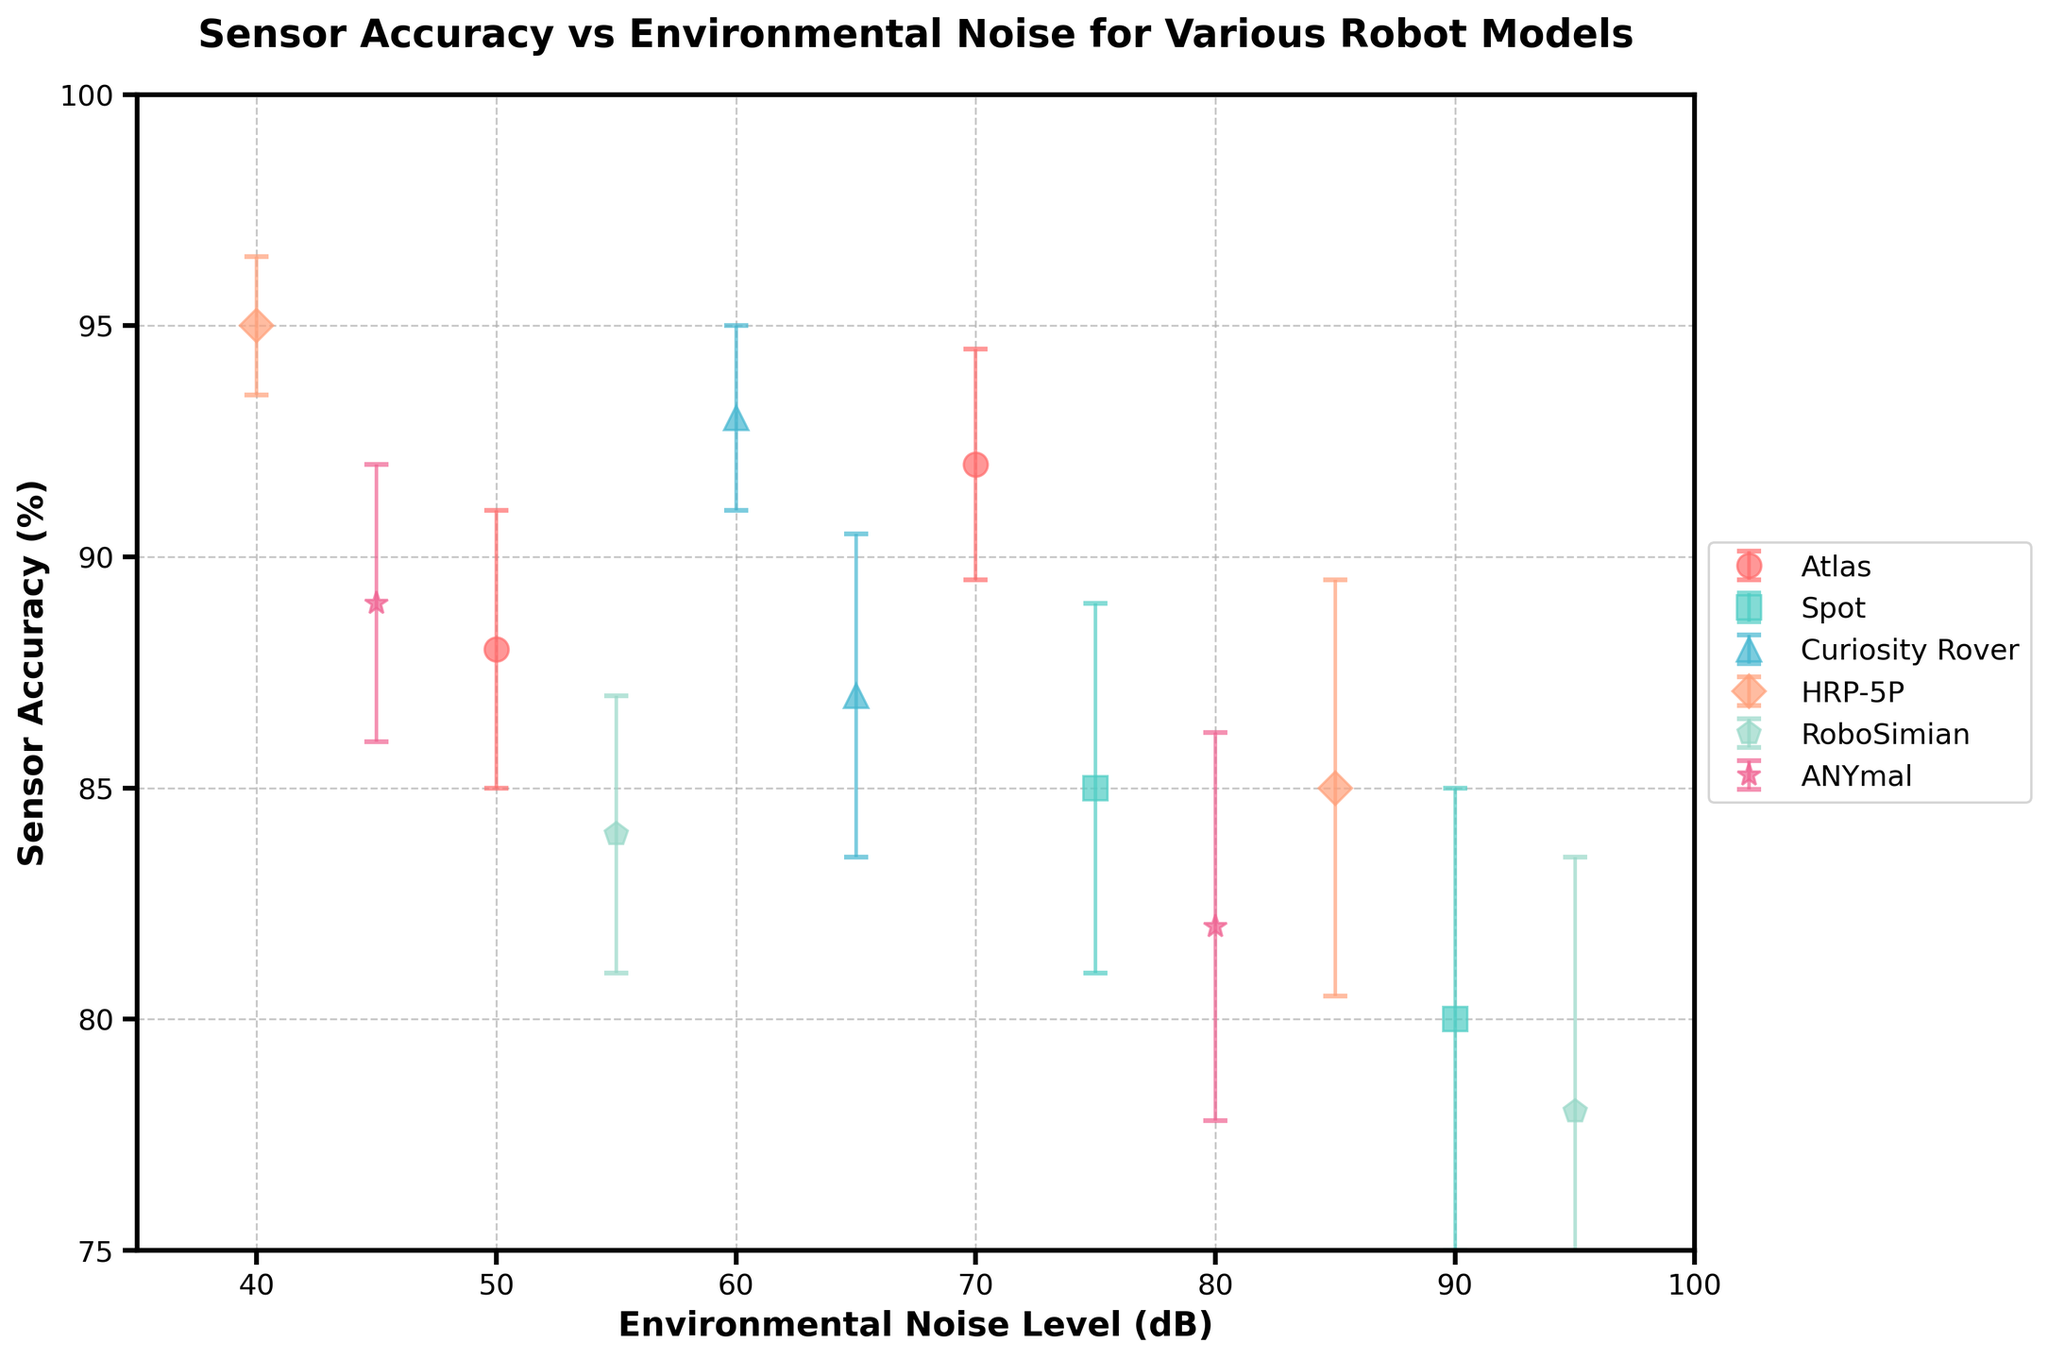what is the highest sensor accuracy value? By observing the y-axis (Sensor Accuracy %) and the plotted data points, the highest value is 95%
Answer: 95% Which robot model has the worst sensor accuracy in high environmental noise levels (greater than 90 dB)? By looking at the x-axis for environmental noise levels greater than 90 dB and identifying the corresponding data points, the worst accuracy is for RoboSimian in Rubble with 78%
Answer: RoboSimian What is the average sensor accuracy for HRP-5P across different environments? HRP-5P has two data points (Indoor: 95% and Outdoor: 85%). The average is (95 + 85) / 2 = 90
Answer: 90 Which robot models do not have data points for environmental noise levels below 50 dB? By examining the x-axis for points below 50 dB and checking the corresponding robot models, Atlas, Spot, HRP-5P, and ANYmal do not have data points in that range
Answer: Atlas, Spot, HRP-5P, ANYmal What is the error margin for the sensor accuracy of Curiosity Rover in the Desert environment? Looking at the data point for Curiosity Rover in the Desert environment on the y-axis (Sensor Accuracy: 93%) and observing the error bars, the error margin is 2.0%
Answer: 2.0% Which robot model performs best in terms of sensor accuracy in an outdoor environment? Comparing the data points with the highest sensor accuracy in outdoor environments, Curiosity Rover in the Desert has an accuracy of 93%, the highest among others
Answer: Curiosity Rover How much less accurate is RoboSimian in Rubble compared to HRP-5P in Indoor environment? RoboSimian in Rubble has a sensor accuracy of 78%, while HRP-5P indoors has 95%. The difference is 95 - 78 = 17%
Answer: 17% Which environment shows the largest error margin for sensor accuracy measurements? By observing the length of error bars across all data points, Spot in Factories (with a margin of 5.0%) has the largest
Answer: Factories Is there a negative correlation between environmental noise and sensor accuracy? Observing the overall trend of the data points, generally, higher environmental noise levels correspond to lower sensor accuracy values which suggests a negative correlation
Answer: Yes 